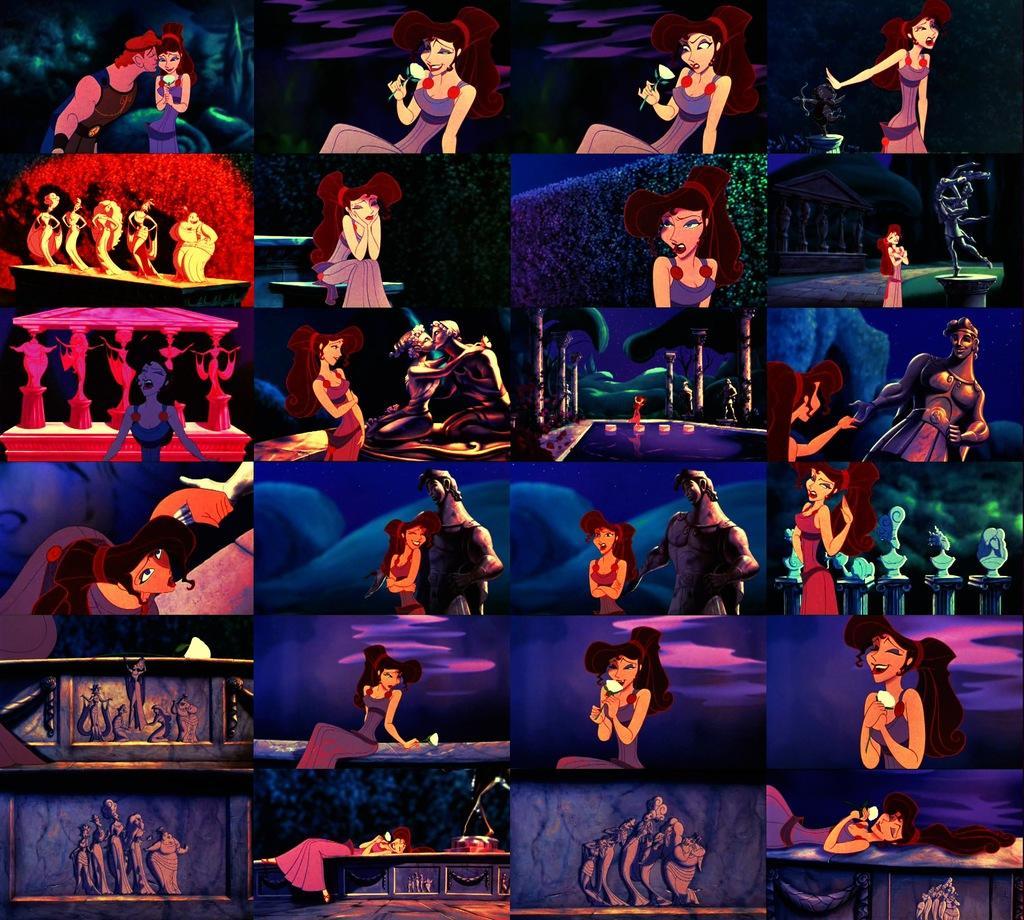Please provide a concise description of this image. In this image we can see collage. In few images we can see cartoon characters. In few images we can see sculptures and few other things. 